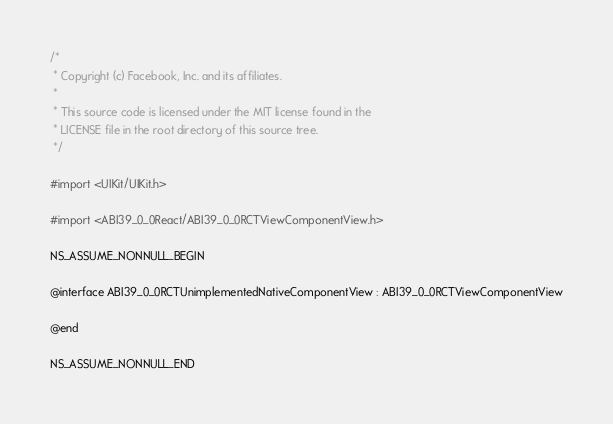Convert code to text. <code><loc_0><loc_0><loc_500><loc_500><_C_>/*
 * Copyright (c) Facebook, Inc. and its affiliates.
 *
 * This source code is licensed under the MIT license found in the
 * LICENSE file in the root directory of this source tree.
 */

#import <UIKit/UIKit.h>

#import <ABI39_0_0React/ABI39_0_0RCTViewComponentView.h>

NS_ASSUME_NONNULL_BEGIN

@interface ABI39_0_0RCTUnimplementedNativeComponentView : ABI39_0_0RCTViewComponentView

@end

NS_ASSUME_NONNULL_END
</code> 